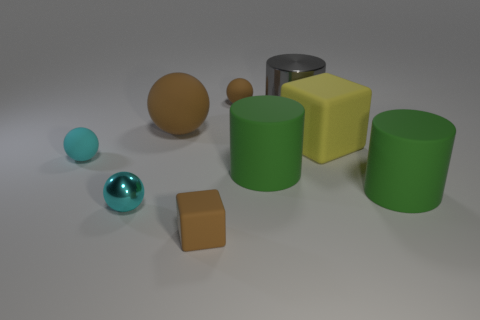Subtract all matte cylinders. How many cylinders are left? 1 Subtract all purple balls. How many green cylinders are left? 2 Add 1 big purple metallic cubes. How many objects exist? 10 Subtract all cylinders. How many objects are left? 6 Subtract 1 balls. How many balls are left? 3 Add 2 balls. How many balls are left? 6 Add 9 blue metallic spheres. How many blue metallic spheres exist? 9 Subtract 0 purple cubes. How many objects are left? 9 Subtract all red cylinders. Subtract all brown spheres. How many cylinders are left? 3 Subtract all yellow objects. Subtract all small brown rubber spheres. How many objects are left? 7 